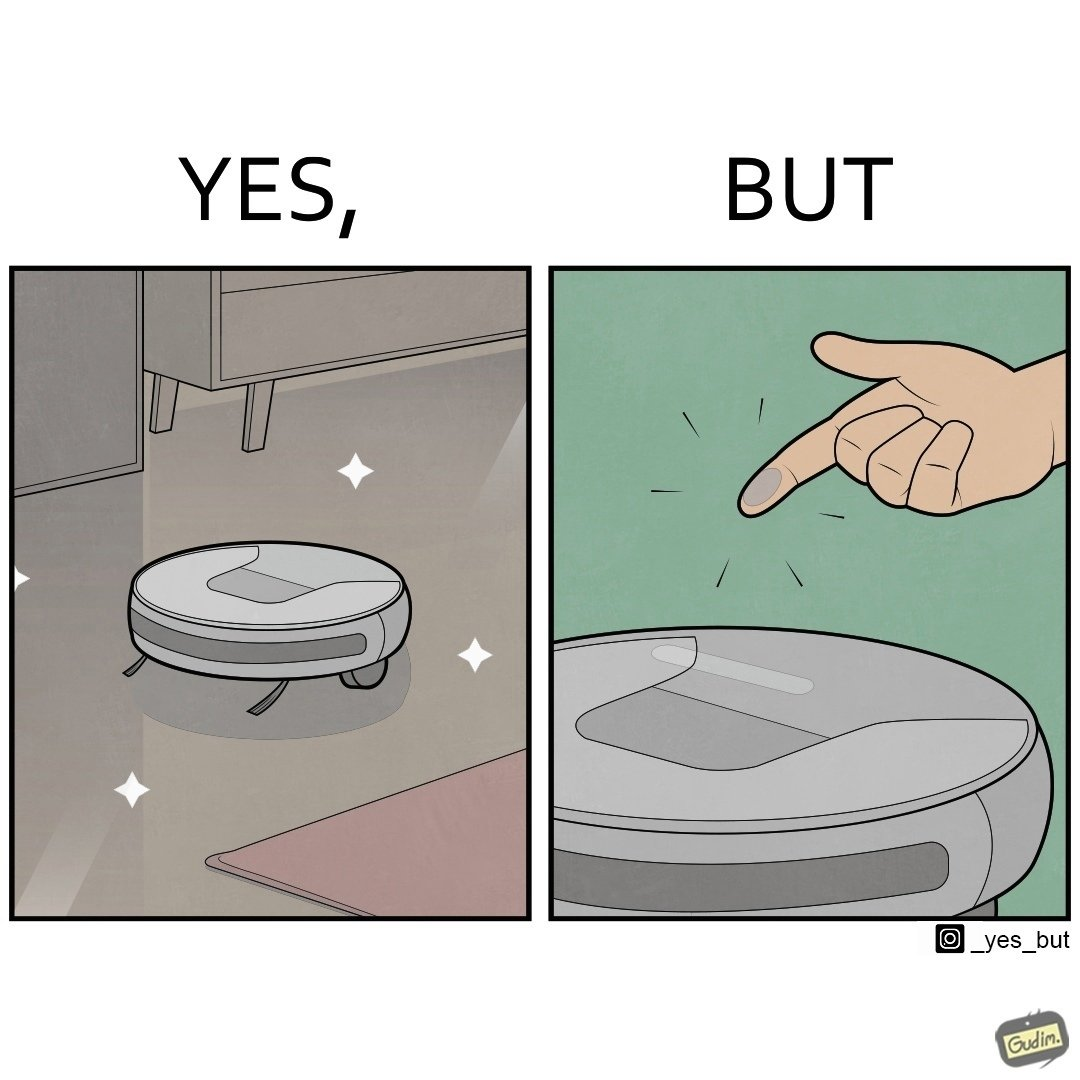Why is this image considered satirical? This is funny, because the machine while doing its job cleans everything but ends up being dirty itself. 